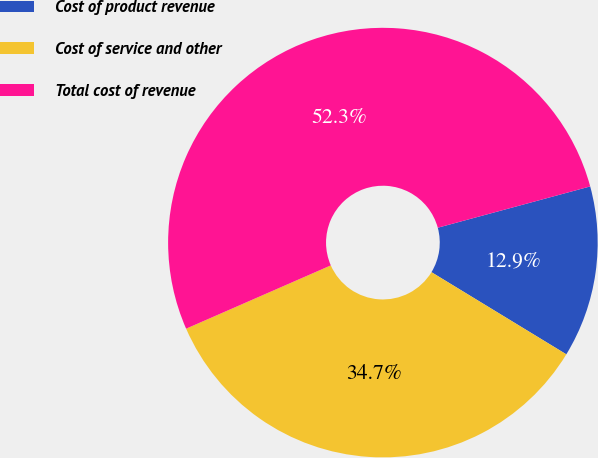<chart> <loc_0><loc_0><loc_500><loc_500><pie_chart><fcel>Cost of product revenue<fcel>Cost of service and other<fcel>Total cost of revenue<nl><fcel>12.92%<fcel>34.73%<fcel>52.35%<nl></chart> 